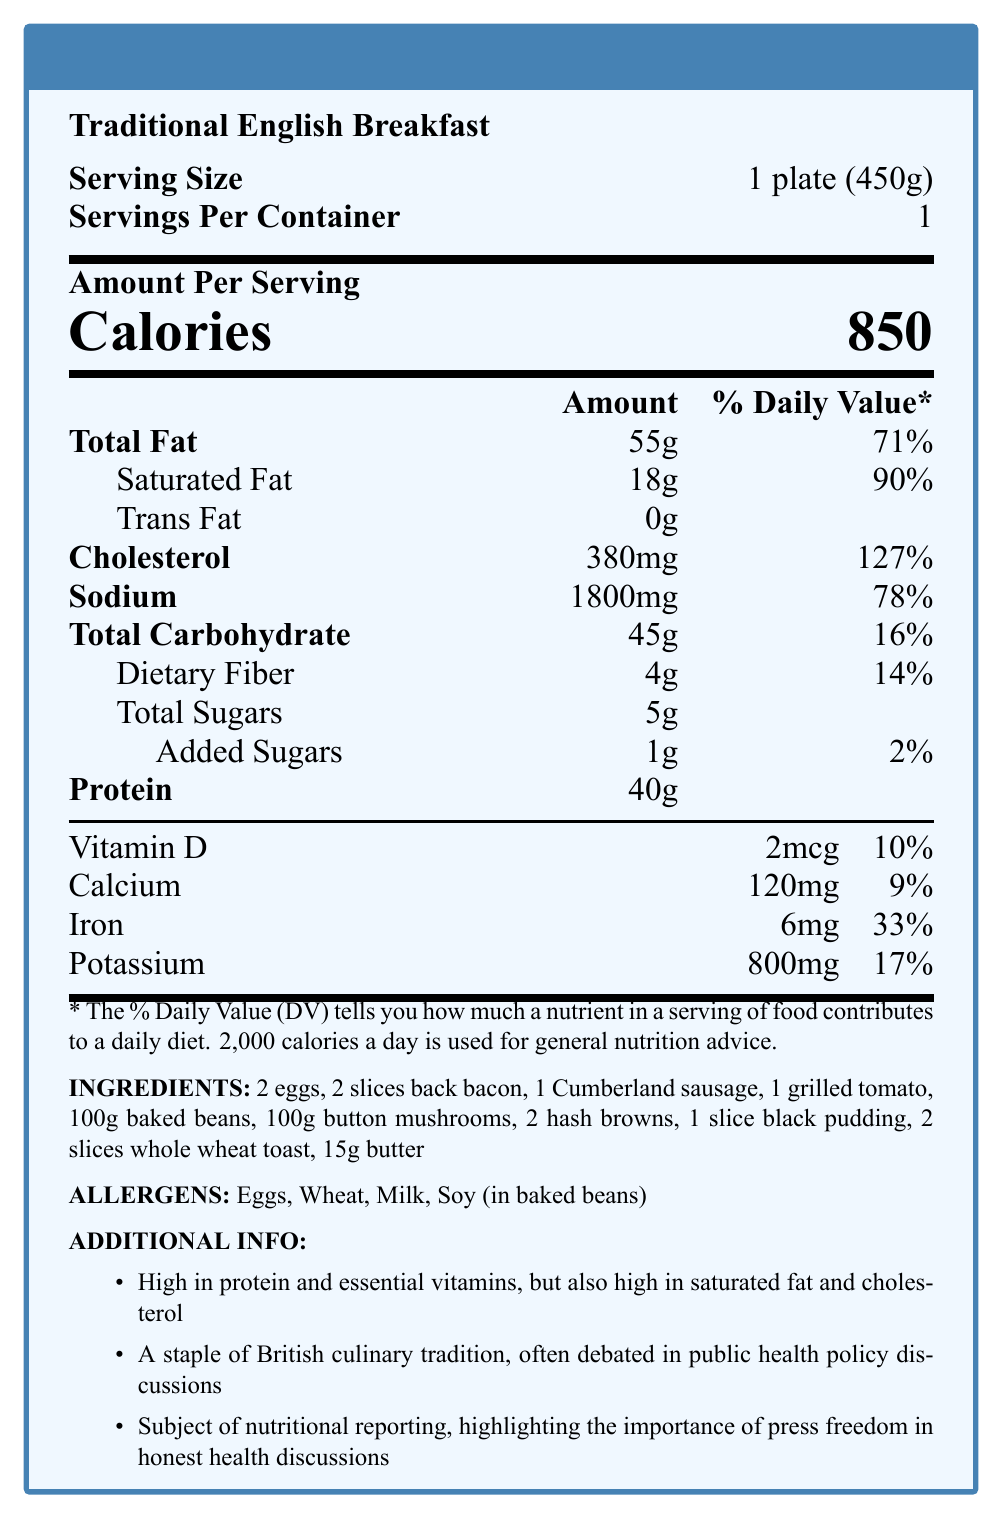What is the serving size for the Traditional English Breakfast? The document explicitly states that the serving size is 1 plate, weighing 450 grams.
Answer: 1 plate (450g) How many calories are in one serving of the Traditional English Breakfast? The document shows that the number of calories per serving is 850 in large, prominent font.
Answer: 850 calories What is the percentage of the Daily Value for saturated fat in the Traditional English Breakfast? The document lists the amount of saturated fat as 18g, corresponding to 90% of the Daily Value.
Answer: 90% Based on the document, how much protein does one serving contain? The protein content per serving is listed as 40g in the document.
Answer: 40g Which ingredient is not included in the Traditional English Breakfast? A. Hash browns B. Poached eggs C. Black pudding D. Cumberland sausage The ingredient list includes hash browns, black pudding, and Cumberland sausage but not poached eggs.
Answer: B. Poached eggs What is the daily percentage value of iron provided by one serving of this breakfast? The document indicates that one serving contains 33% of the Daily Value for iron.
Answer: 33% Is the document mentioning any trans fat content in the Traditional English Breakfast? The document states that the trans fat content is 0g.
Answer: No What total amount of sodium does one serving contain, and what percentage of the daily value does it represent? Sodium content is 1800mg, which represents 78% of the Daily Value, as given in the document.
Answer: 1800mg, 78% Which vitamin is provided at 10% of the Daily Value by the Traditional English Breakfast? A. Vitamin A B. Vitamin B12 C. Vitamin D D. Vitamin C The document specifically states that Vitamin D is provided at 10% of the Daily Value.
Answer: C. Vitamin D Summarize the nutritional characteristics and context of the Traditional English Breakfast as presented in the document. The document describes the high protein and essential vitamins but also high saturated fat and cholesterol content. It notes the cultural and political context and the role of journalistic freedom in discussing such foods.
Answer: The Traditional English Breakfast offers a high-protein meal with essential vitamins and minerals but is also high in saturated fat and cholesterol. It's a staple of British tradition with both culinary admiration and health critiques, highlighting the necessity of press freedom in nutritional discussions. Does the Traditional English Breakfast include whole wheat toast among its ingredients? The ingredients section of the document includes "2 slices whole wheat toast."
Answer: Yes What is the total carbohydrate content and the percentage of the Daily Value for a serving of this breakfast? The document lists 45g of total carbohydrates, which is 16% of the Daily Value.
Answer: 45g, 16% Is the Traditional English Breakfast listed as subject to public health policy discussions regarding obesity rates in the UK? The additional info section mentions the breakfast is often debated in public health policy discussions regarding obesity rates.
Answer: Yes What allergens are present in the Traditional English Breakfast? Name at least two. The allergens listed in the document include Eggs, Wheat, Milk, and Soy (in baked beans).
Answer: Eggs, Wheat For the total fat content in the Traditional English Breakfast, what percentage of the daily value does it meet? A. 50% B. 60% C. 71% D. 80% The document provides that the total fat content of 55g meets 71% of the Daily Value.
Answer: C. 71% What is the calorie breakdown by macronutrient in the Traditional English Breakfast? The document provides a specific breakdown: 495 calories from fat, 160 from protein, and 195 from carbohydrates.
Answer: Fat Calories: 495, Protein Calories: 160, Carbohydrate Calories: 195 What is the political implication mentioned in the document regarding the Traditional English Breakfast? The additional info highlights its role in public health policy debates about obesity rates in the UK.
Answer: Subject of debate in public health policy discussions regarding obesity rates in the UK What is the potassium content and its corresponding percentage Daily Value in one serving of the Traditional English Breakfast? The potassium content is 800mg, which is 17% of the Daily Value.
Answer: 800mg, 17% Can you determine the daily caloric needs for an individual from the information given in the document? The document states general nutrition advice uses 2,000 calories but doesn't specify individual needs.
Answer: Cannot be determined Which of the following statements best describes the Traditional English Breakfast based on nutrient density? A. Low in protein and vitamins B. High in sugar and sodium C. High in protein and essential vitamins, but also high in saturated fat and cholesterol D. Low in calories but high in carbohydrates The document describes it as high in protein and essential vitamins but also high in saturated fat and cholesterol.
Answer: C. High in protein and essential vitamins, but also high in saturated fat and cholesterol 